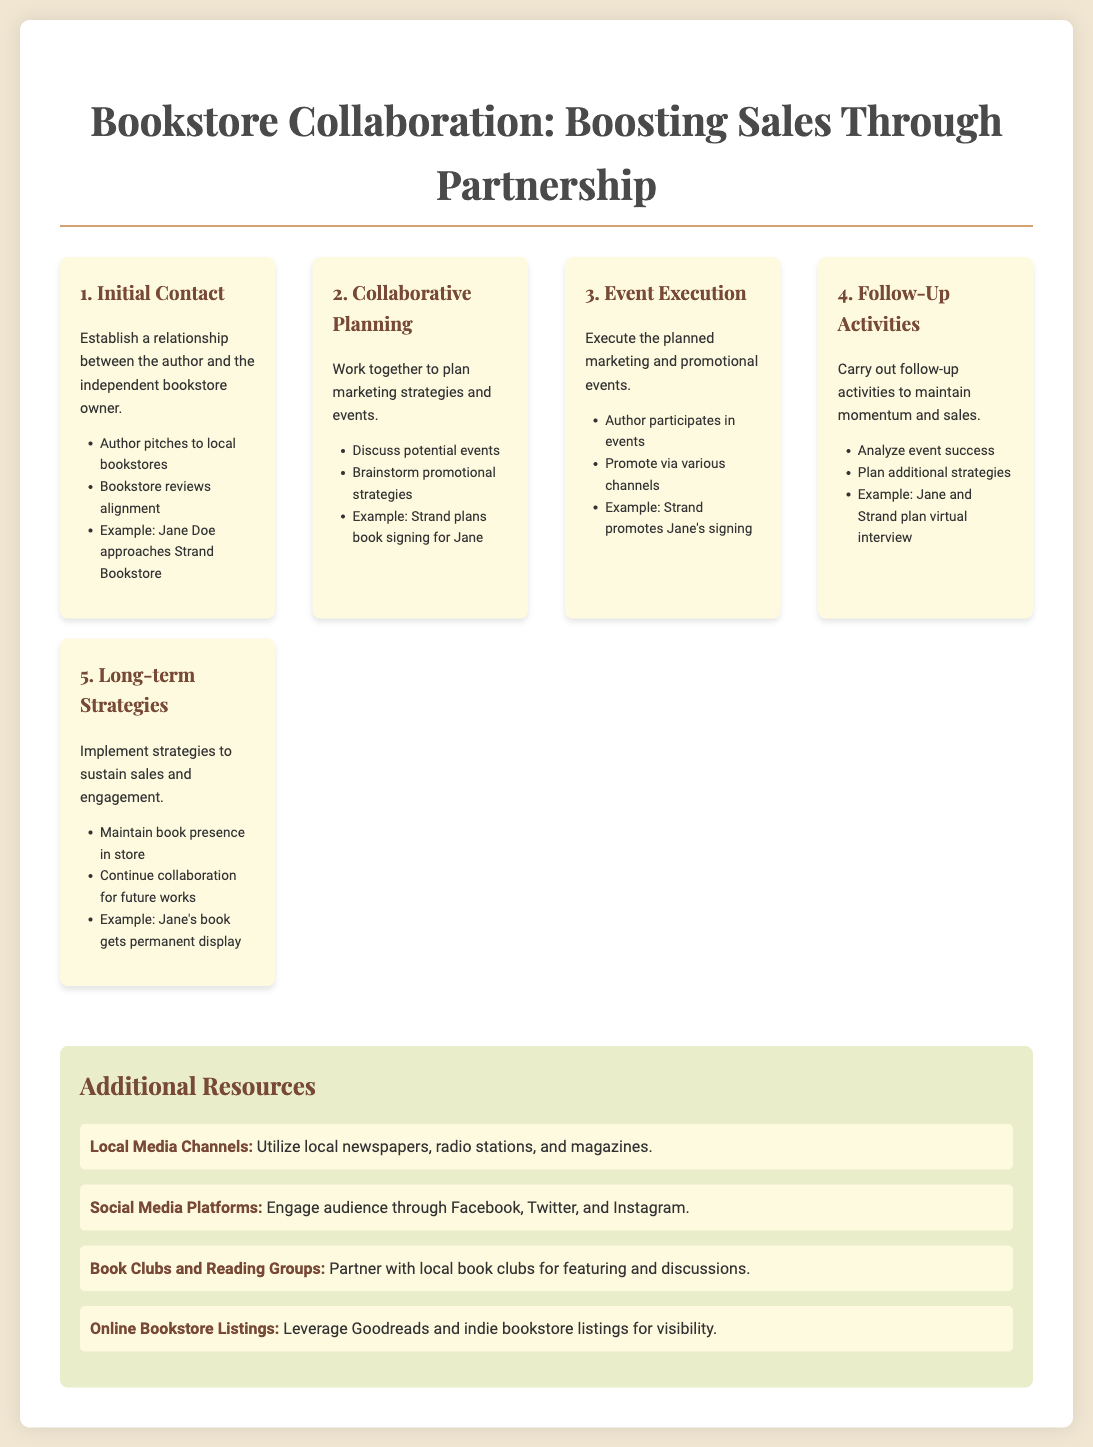What is the title of the document? The title of the document is presented prominently at the top, which is "Bookstore Collaboration: Boosting Sales Through Partnership."
Answer: Bookstore Collaboration: Boosting Sales Through Partnership What is the first step in the collaborative marketing process? The first step in the process is listed as "Initial Contact."
Answer: Initial Contact How many steps are outlined in the process? The document provides a total of five steps in the collaborative process.
Answer: 5 What example is given for the event execution step? An example provided for this step is related to the participation of the author in events, specifically mentioning "Strand promotes Jane's signing."
Answer: Strand promotes Jane's signing Which social media platforms are suggested as resources? The document mentions engaging the audience through three platforms: Facebook, Twitter, and Instagram.
Answer: Facebook, Twitter, and Instagram What happens during the collaborative planning step? This step involves discussing potential events and brainstorming promotional strategies.
Answer: Discuss potential events and brainstorm promotional strategies What is a follow-up activity mentioned in the document? One follow-up activity mentioned is to "analyze event success."
Answer: Analyze event success What marketing resource involves local organizations? The resource that involves local organizations is partnering with "local book clubs for featuring and discussions."
Answer: Local book clubs for featuring and discussions What is a long-term strategy mentioned in the document? Maintaining a book presence in the store is one of the long-term strategies discussed.
Answer: Maintain book presence in store 